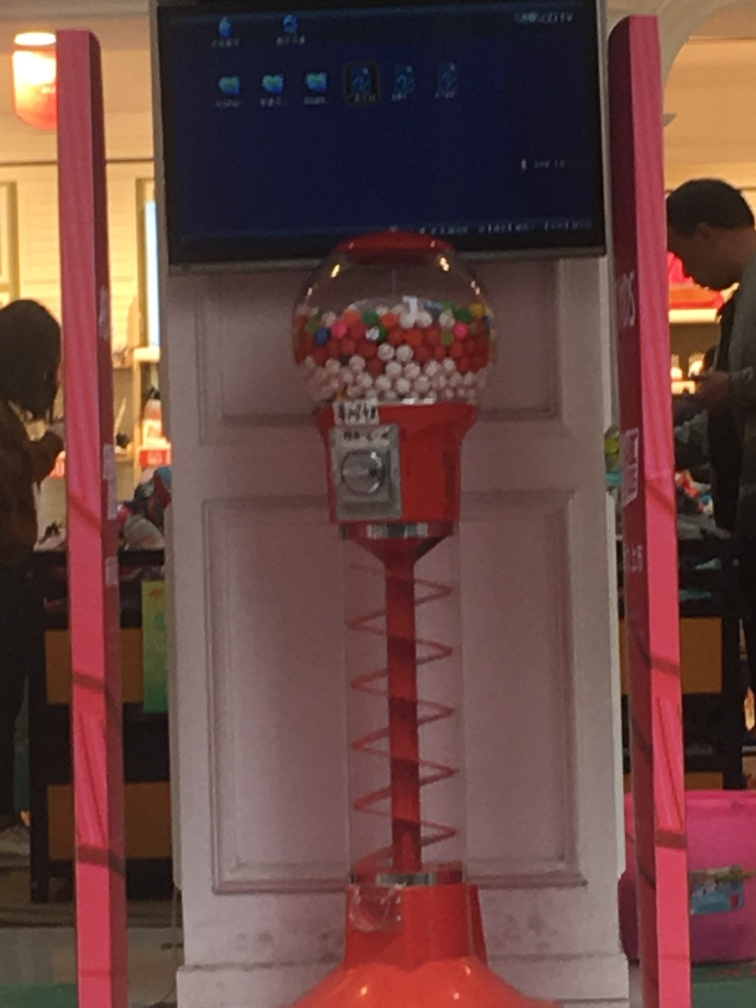Are texture details of the main subject preserved well? Based on the resolution and quality of the image provided, it appears that the texture details of the gumball machine, which is the main subject, are somewhat preserved. However, there is noticeable blurriness and pixelation which obscures finer texture details. The image quality does not allow for a clear inspection of the surface texture such as the smoothness of the metal or the clarity of the individual gumballs. 